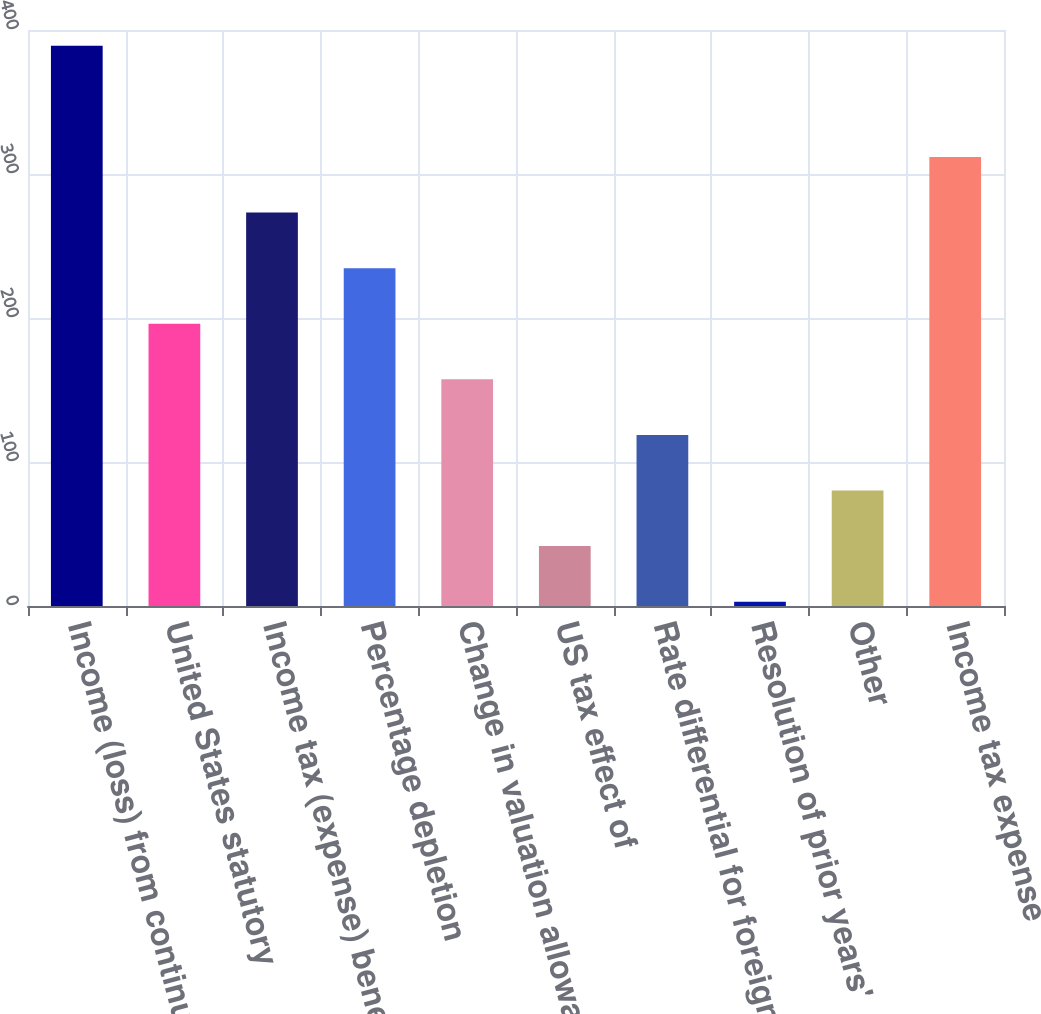Convert chart to OTSL. <chart><loc_0><loc_0><loc_500><loc_500><bar_chart><fcel>Income (loss) from continuing<fcel>United States statutory<fcel>Income tax (expense) benefit<fcel>Percentage depletion<fcel>Change in valuation allowance<fcel>US tax effect of<fcel>Rate differential for foreign<fcel>Resolution of prior years'<fcel>Other<fcel>Income tax expense<nl><fcel>389<fcel>196<fcel>273.2<fcel>234.6<fcel>157.4<fcel>41.6<fcel>118.8<fcel>3<fcel>80.2<fcel>311.8<nl></chart> 